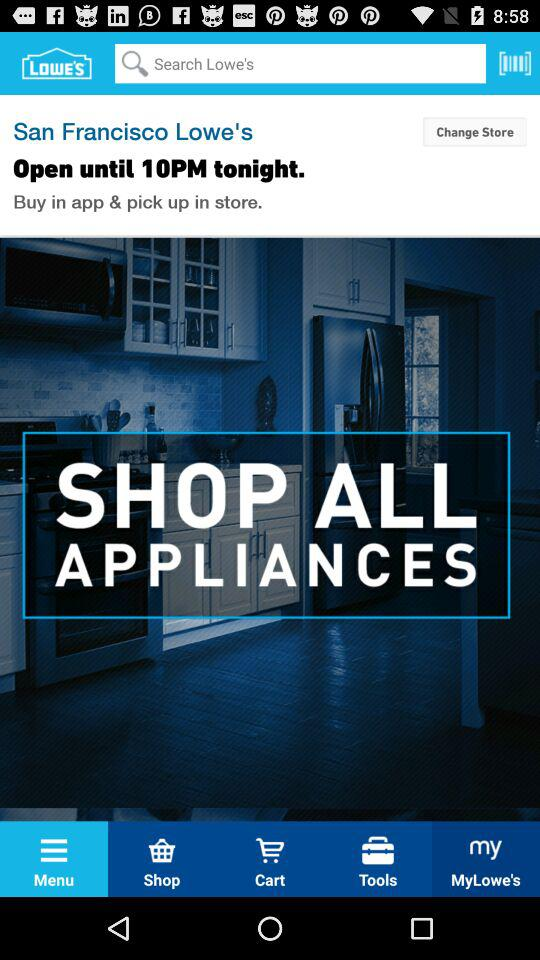Which tab is currently selected? The tab "Menu" is currently selected. 